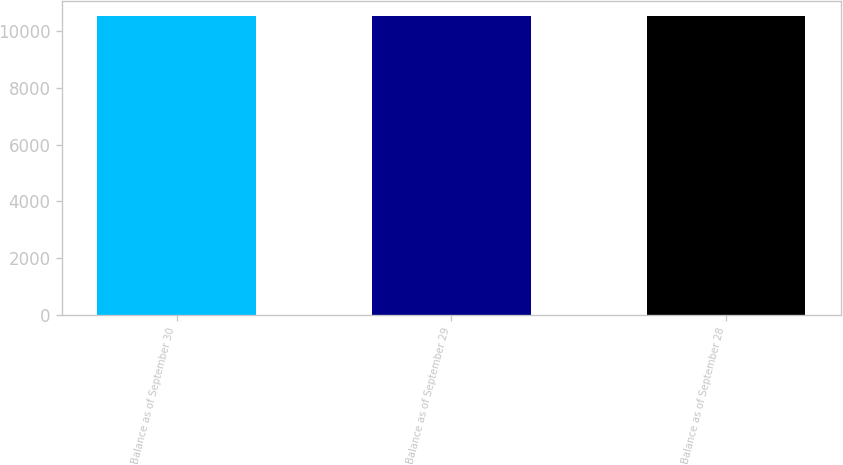Convert chart. <chart><loc_0><loc_0><loc_500><loc_500><bar_chart><fcel>Balance as of September 30<fcel>Balance as of September 29<fcel>Balance as of September 28<nl><fcel>10550<fcel>10550.1<fcel>10550.2<nl></chart> 